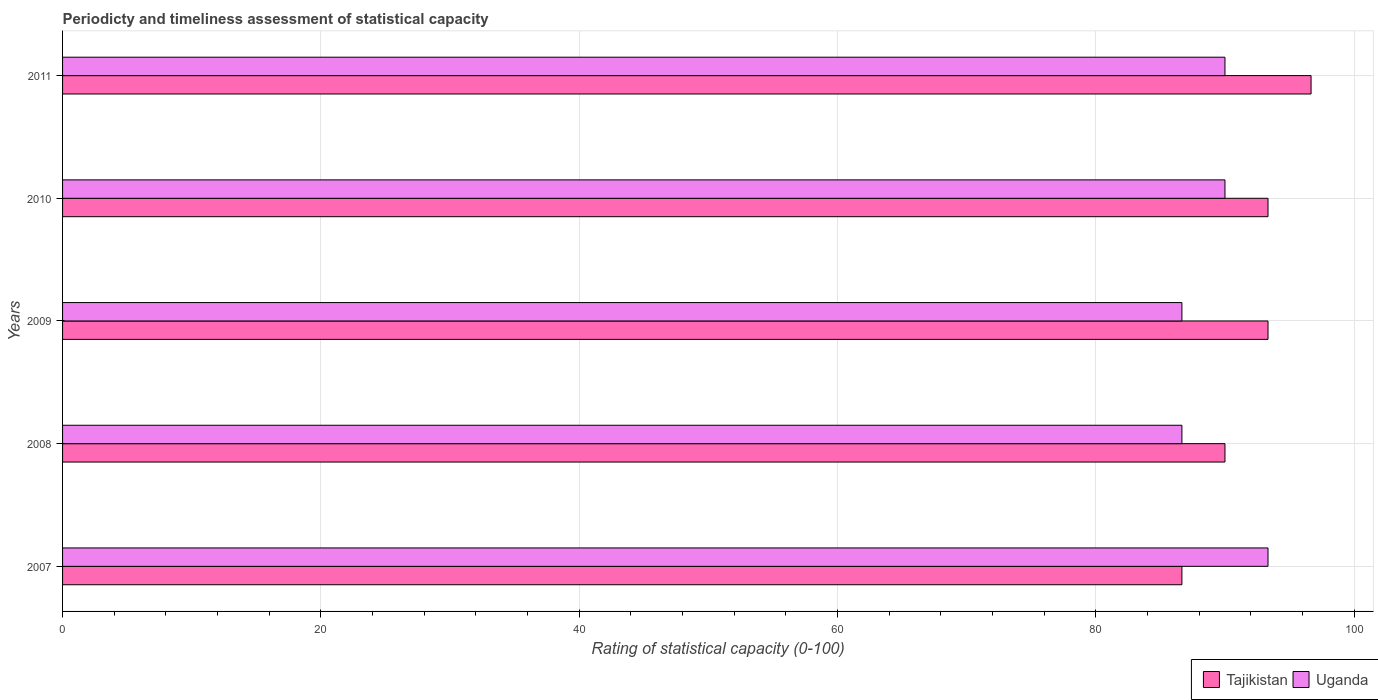How many different coloured bars are there?
Keep it short and to the point. 2. What is the label of the 2nd group of bars from the top?
Provide a short and direct response. 2010. What is the rating of statistical capacity in Uganda in 2010?
Your answer should be very brief. 90. Across all years, what is the maximum rating of statistical capacity in Uganda?
Offer a very short reply. 93.33. Across all years, what is the minimum rating of statistical capacity in Tajikistan?
Make the answer very short. 86.67. What is the total rating of statistical capacity in Tajikistan in the graph?
Your response must be concise. 460. What is the difference between the rating of statistical capacity in Uganda in 2007 and that in 2010?
Your answer should be compact. 3.33. What is the difference between the rating of statistical capacity in Uganda in 2010 and the rating of statistical capacity in Tajikistan in 2008?
Offer a very short reply. 0. What is the average rating of statistical capacity in Tajikistan per year?
Give a very brief answer. 92. In the year 2011, what is the difference between the rating of statistical capacity in Uganda and rating of statistical capacity in Tajikistan?
Provide a short and direct response. -6.67. In how many years, is the rating of statistical capacity in Uganda greater than 80 ?
Give a very brief answer. 5. What is the ratio of the rating of statistical capacity in Uganda in 2007 to that in 2011?
Your answer should be very brief. 1.04. What is the difference between the highest and the second highest rating of statistical capacity in Tajikistan?
Ensure brevity in your answer.  3.33. What is the difference between the highest and the lowest rating of statistical capacity in Tajikistan?
Give a very brief answer. 10. Is the sum of the rating of statistical capacity in Tajikistan in 2007 and 2010 greater than the maximum rating of statistical capacity in Uganda across all years?
Make the answer very short. Yes. What does the 2nd bar from the top in 2007 represents?
Keep it short and to the point. Tajikistan. What does the 2nd bar from the bottom in 2007 represents?
Offer a terse response. Uganda. How many bars are there?
Your answer should be very brief. 10. Are all the bars in the graph horizontal?
Your answer should be very brief. Yes. How many years are there in the graph?
Your response must be concise. 5. What is the difference between two consecutive major ticks on the X-axis?
Your answer should be compact. 20. Does the graph contain grids?
Give a very brief answer. Yes. What is the title of the graph?
Your answer should be compact. Periodicty and timeliness assessment of statistical capacity. What is the label or title of the X-axis?
Give a very brief answer. Rating of statistical capacity (0-100). What is the label or title of the Y-axis?
Make the answer very short. Years. What is the Rating of statistical capacity (0-100) in Tajikistan in 2007?
Your answer should be compact. 86.67. What is the Rating of statistical capacity (0-100) in Uganda in 2007?
Your response must be concise. 93.33. What is the Rating of statistical capacity (0-100) in Uganda in 2008?
Provide a short and direct response. 86.67. What is the Rating of statistical capacity (0-100) of Tajikistan in 2009?
Offer a very short reply. 93.33. What is the Rating of statistical capacity (0-100) in Uganda in 2009?
Offer a very short reply. 86.67. What is the Rating of statistical capacity (0-100) of Tajikistan in 2010?
Keep it short and to the point. 93.33. What is the Rating of statistical capacity (0-100) in Tajikistan in 2011?
Give a very brief answer. 96.67. Across all years, what is the maximum Rating of statistical capacity (0-100) of Tajikistan?
Provide a succinct answer. 96.67. Across all years, what is the maximum Rating of statistical capacity (0-100) of Uganda?
Provide a succinct answer. 93.33. Across all years, what is the minimum Rating of statistical capacity (0-100) in Tajikistan?
Keep it short and to the point. 86.67. Across all years, what is the minimum Rating of statistical capacity (0-100) in Uganda?
Your answer should be compact. 86.67. What is the total Rating of statistical capacity (0-100) of Tajikistan in the graph?
Your response must be concise. 460. What is the total Rating of statistical capacity (0-100) in Uganda in the graph?
Your response must be concise. 446.67. What is the difference between the Rating of statistical capacity (0-100) of Tajikistan in 2007 and that in 2009?
Make the answer very short. -6.67. What is the difference between the Rating of statistical capacity (0-100) of Uganda in 2007 and that in 2009?
Make the answer very short. 6.67. What is the difference between the Rating of statistical capacity (0-100) in Tajikistan in 2007 and that in 2010?
Your answer should be compact. -6.67. What is the difference between the Rating of statistical capacity (0-100) of Uganda in 2007 and that in 2010?
Make the answer very short. 3.33. What is the difference between the Rating of statistical capacity (0-100) in Tajikistan in 2007 and that in 2011?
Offer a very short reply. -10. What is the difference between the Rating of statistical capacity (0-100) in Tajikistan in 2008 and that in 2009?
Make the answer very short. -3.33. What is the difference between the Rating of statistical capacity (0-100) in Uganda in 2008 and that in 2009?
Give a very brief answer. 0. What is the difference between the Rating of statistical capacity (0-100) in Tajikistan in 2008 and that in 2010?
Offer a terse response. -3.33. What is the difference between the Rating of statistical capacity (0-100) in Uganda in 2008 and that in 2010?
Ensure brevity in your answer.  -3.33. What is the difference between the Rating of statistical capacity (0-100) in Tajikistan in 2008 and that in 2011?
Provide a short and direct response. -6.67. What is the difference between the Rating of statistical capacity (0-100) in Uganda in 2008 and that in 2011?
Keep it short and to the point. -3.33. What is the difference between the Rating of statistical capacity (0-100) in Tajikistan in 2009 and that in 2010?
Ensure brevity in your answer.  0. What is the difference between the Rating of statistical capacity (0-100) in Uganda in 2009 and that in 2010?
Provide a short and direct response. -3.33. What is the difference between the Rating of statistical capacity (0-100) of Tajikistan in 2009 and that in 2011?
Provide a short and direct response. -3.33. What is the difference between the Rating of statistical capacity (0-100) in Tajikistan in 2010 and that in 2011?
Offer a very short reply. -3.33. What is the difference between the Rating of statistical capacity (0-100) of Uganda in 2010 and that in 2011?
Ensure brevity in your answer.  0. What is the difference between the Rating of statistical capacity (0-100) in Tajikistan in 2007 and the Rating of statistical capacity (0-100) in Uganda in 2010?
Ensure brevity in your answer.  -3.33. What is the difference between the Rating of statistical capacity (0-100) of Tajikistan in 2008 and the Rating of statistical capacity (0-100) of Uganda in 2009?
Keep it short and to the point. 3.33. What is the difference between the Rating of statistical capacity (0-100) of Tajikistan in 2008 and the Rating of statistical capacity (0-100) of Uganda in 2011?
Keep it short and to the point. 0. What is the difference between the Rating of statistical capacity (0-100) in Tajikistan in 2009 and the Rating of statistical capacity (0-100) in Uganda in 2010?
Offer a very short reply. 3.33. What is the difference between the Rating of statistical capacity (0-100) in Tajikistan in 2009 and the Rating of statistical capacity (0-100) in Uganda in 2011?
Offer a terse response. 3.33. What is the average Rating of statistical capacity (0-100) of Tajikistan per year?
Provide a succinct answer. 92. What is the average Rating of statistical capacity (0-100) in Uganda per year?
Your answer should be very brief. 89.33. In the year 2007, what is the difference between the Rating of statistical capacity (0-100) in Tajikistan and Rating of statistical capacity (0-100) in Uganda?
Provide a succinct answer. -6.67. In the year 2008, what is the difference between the Rating of statistical capacity (0-100) of Tajikistan and Rating of statistical capacity (0-100) of Uganda?
Provide a short and direct response. 3.33. In the year 2011, what is the difference between the Rating of statistical capacity (0-100) in Tajikistan and Rating of statistical capacity (0-100) in Uganda?
Your answer should be compact. 6.67. What is the ratio of the Rating of statistical capacity (0-100) in Tajikistan in 2007 to that in 2008?
Offer a terse response. 0.96. What is the ratio of the Rating of statistical capacity (0-100) in Tajikistan in 2007 to that in 2009?
Offer a terse response. 0.93. What is the ratio of the Rating of statistical capacity (0-100) of Uganda in 2007 to that in 2009?
Your response must be concise. 1.08. What is the ratio of the Rating of statistical capacity (0-100) in Uganda in 2007 to that in 2010?
Make the answer very short. 1.04. What is the ratio of the Rating of statistical capacity (0-100) in Tajikistan in 2007 to that in 2011?
Make the answer very short. 0.9. What is the ratio of the Rating of statistical capacity (0-100) of Tajikistan in 2008 to that in 2010?
Offer a very short reply. 0.96. What is the ratio of the Rating of statistical capacity (0-100) in Uganda in 2008 to that in 2010?
Offer a very short reply. 0.96. What is the ratio of the Rating of statistical capacity (0-100) in Tajikistan in 2008 to that in 2011?
Your response must be concise. 0.93. What is the ratio of the Rating of statistical capacity (0-100) of Tajikistan in 2009 to that in 2011?
Your response must be concise. 0.97. What is the ratio of the Rating of statistical capacity (0-100) in Tajikistan in 2010 to that in 2011?
Keep it short and to the point. 0.97. What is the difference between the highest and the second highest Rating of statistical capacity (0-100) in Tajikistan?
Ensure brevity in your answer.  3.33. 